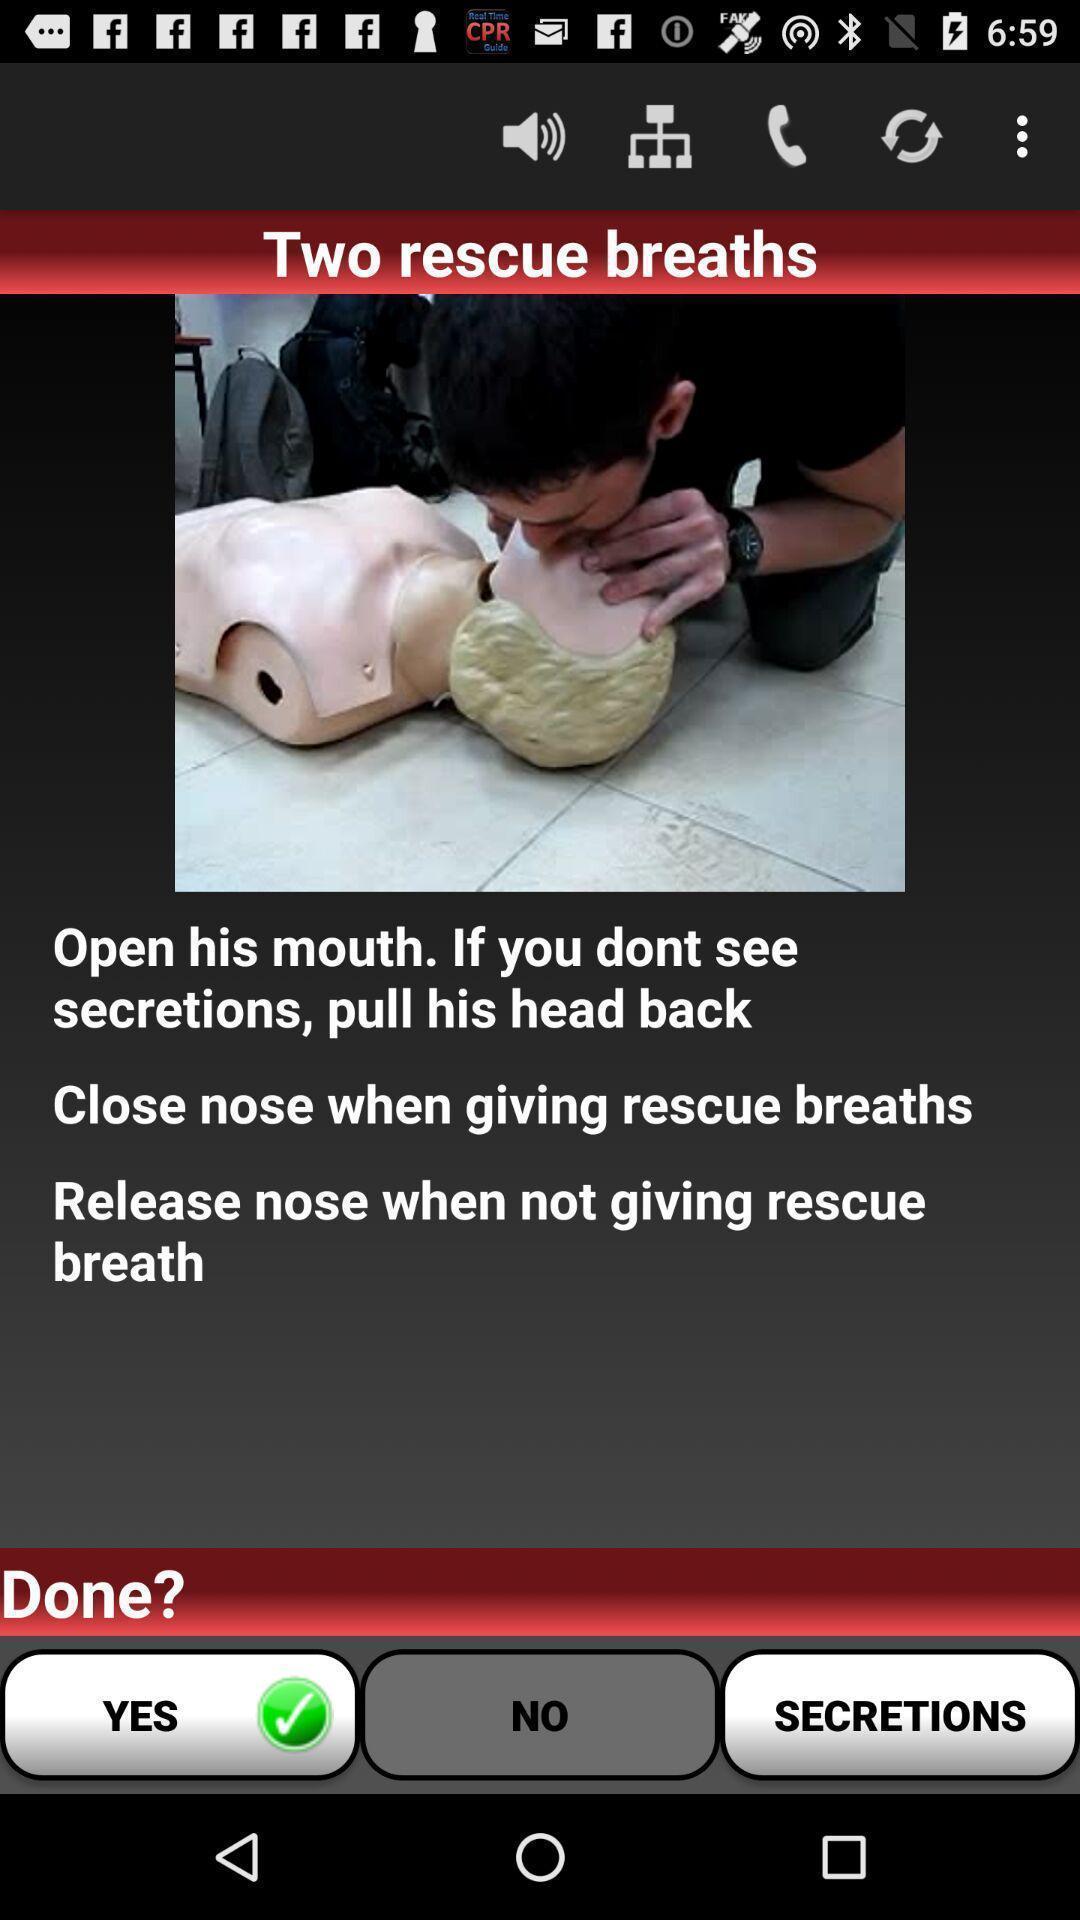Provide a description of this screenshot. Screen shows rescue breath details in a health app. 